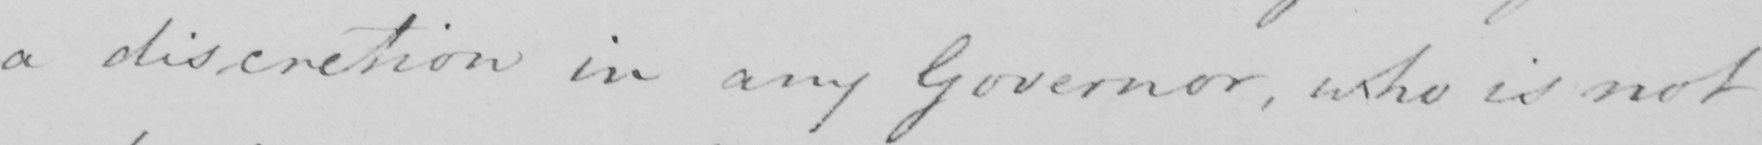Please provide the text content of this handwritten line. a discretion in any Government , who is not 